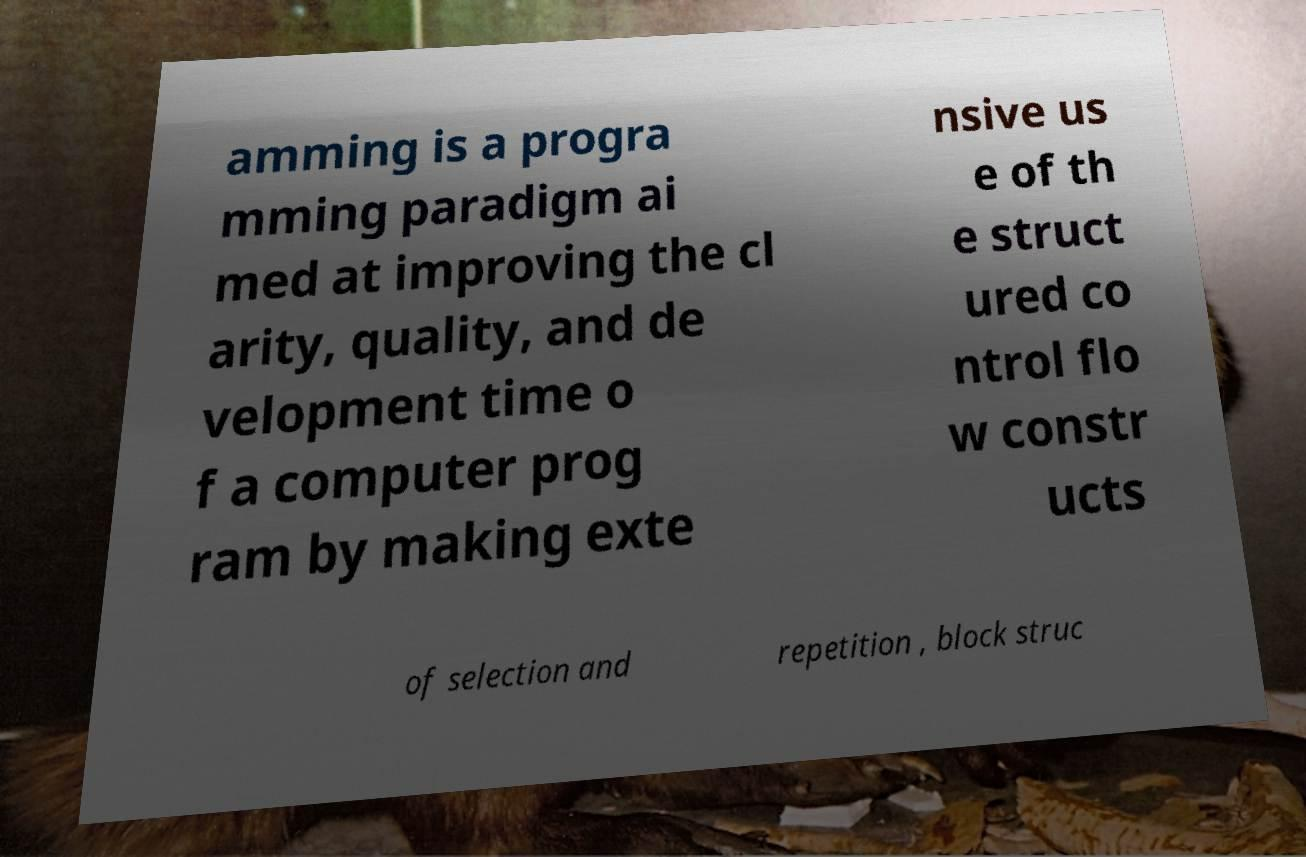Could you extract and type out the text from this image? amming is a progra mming paradigm ai med at improving the cl arity, quality, and de velopment time o f a computer prog ram by making exte nsive us e of th e struct ured co ntrol flo w constr ucts of selection and repetition , block struc 